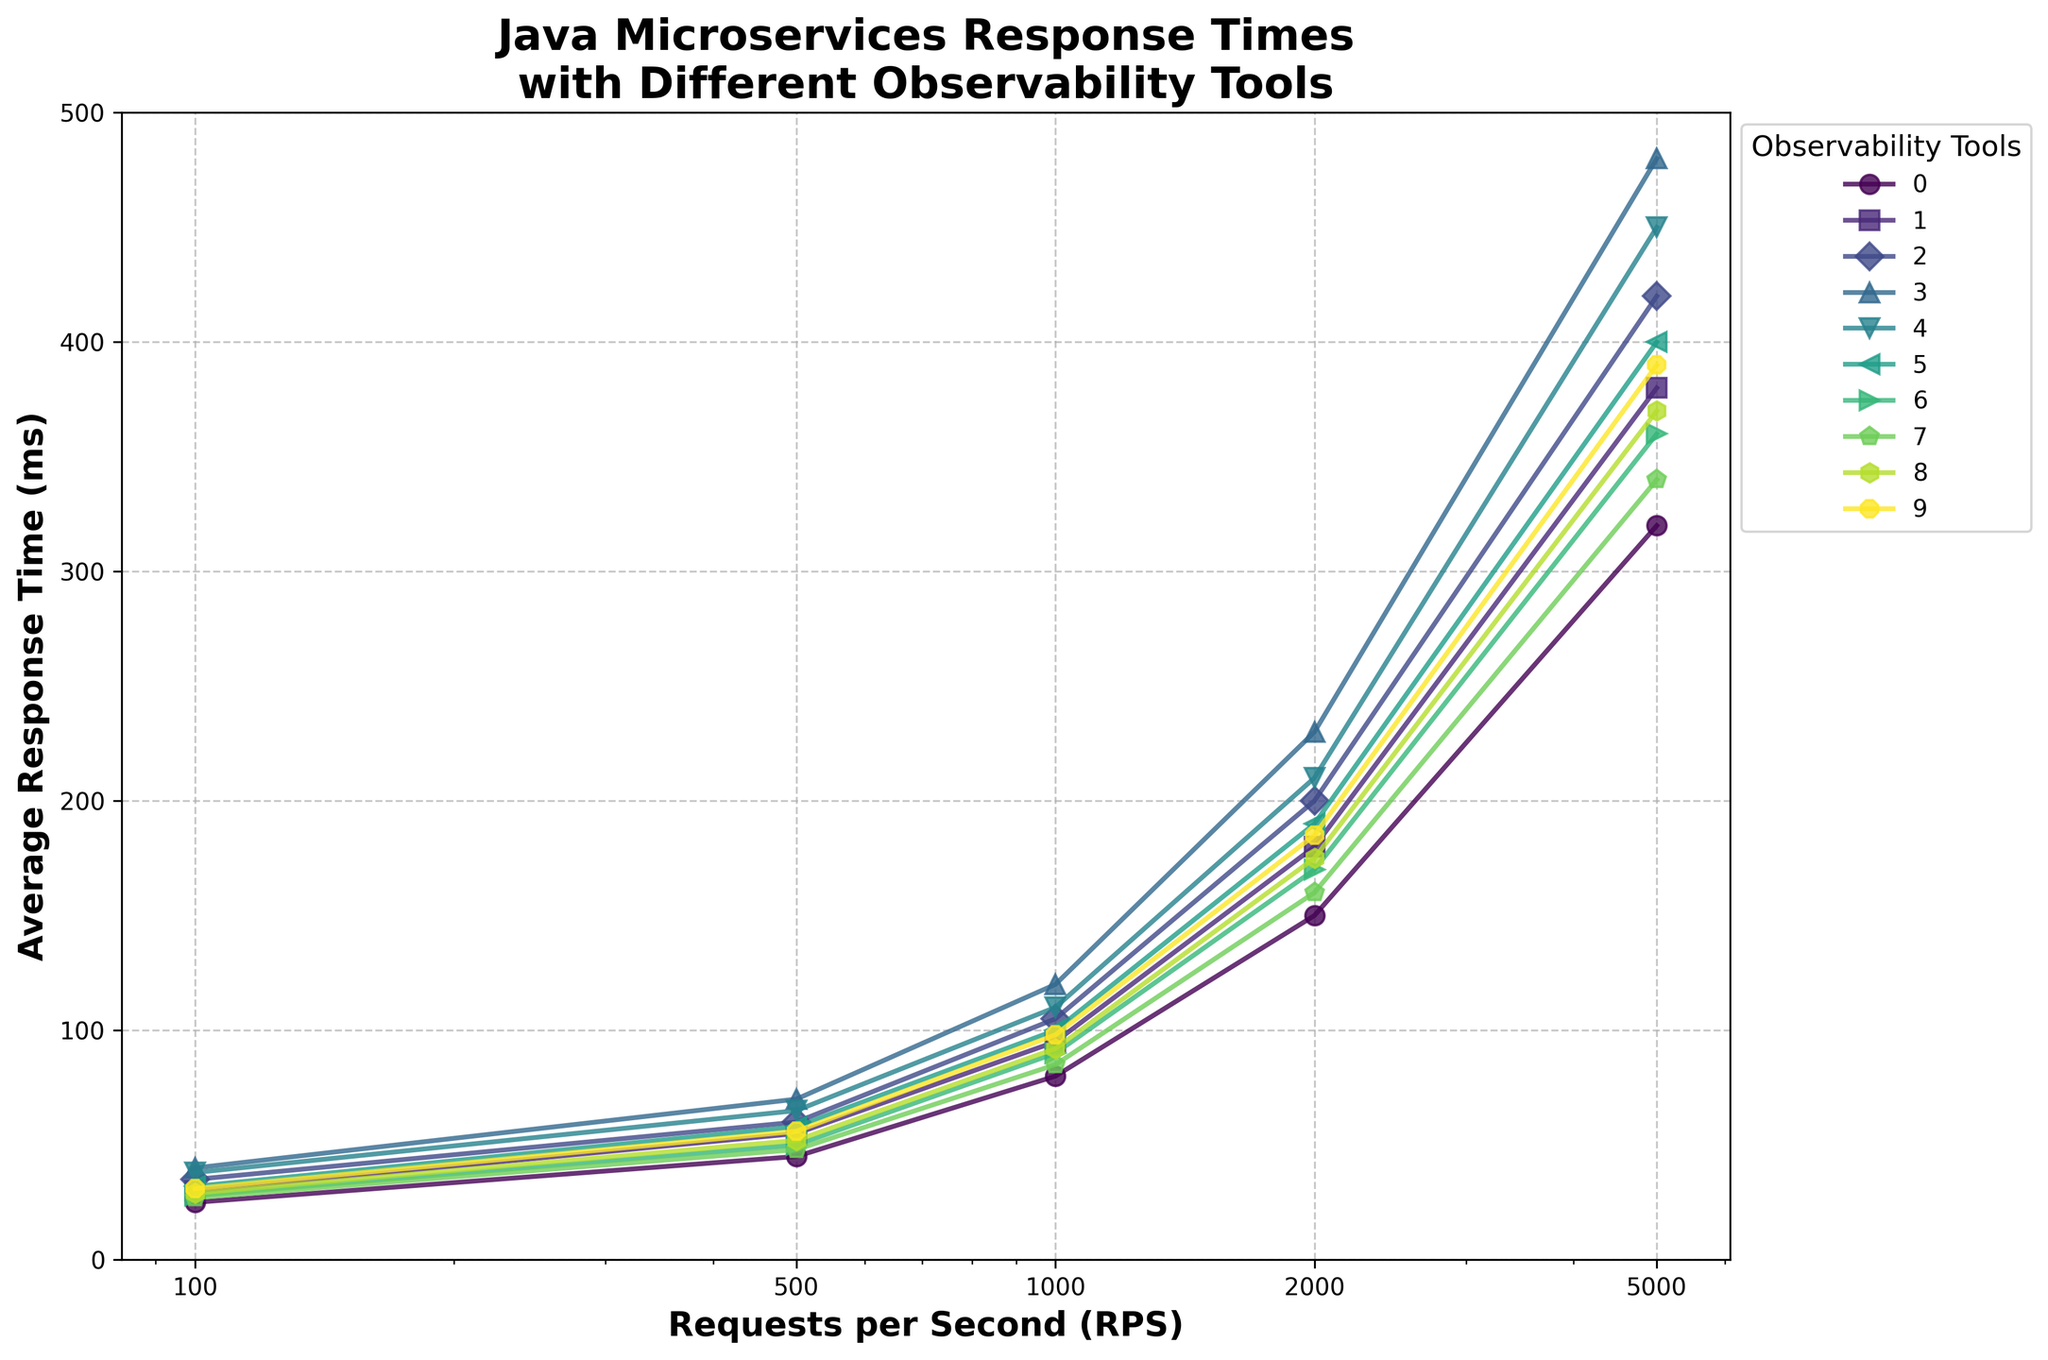What observability tool has the lowest average response time at 100 RPS? Look at the response times for all tools at 100 RPS in the figure. Compare the values and find the smallest one.
Answer: Spring Boot Actuator Which observability tool shows the fastest increase in average response time from 1000 RPS to 2000 RPS? Calculate the difference in response times between 1000 RPS and 2000 RPS for each tool. Identify the tool with the largest increase.
Answer: Jaeger Among the observability tools, which one has a higher average response time at 5000 RPS: OpenTelemetry or Zipkin? Compare the average response times of OpenTelemetry and Zipkin at 5000 RPS directly from the figure.
Answer: Zipkin What's the average response time for Datadog APM at 100 RPS and 5000 RPS? Add the response times of Datadog APM at 100 RPS and 5000 RPS, then divide by 2 to find the average.
Answer: 210.5 ms Which observability tool has a response time of around 170 ms at 2000 RPS? Refer to the response times at 2000 RPS for all tools in the figure and find the value that is nearest to 170 ms.
Answer: New Relic At 1000 RPS, is there any observability tool performing better than Dynatrace? Compare the average response time values of Dynatrace with all other tools at 1000 RPS. Determine if any tools have lower response times.
Answer: Yes, Spring Boot Actuator Which tool has the least variance in response times across all RPS levels? Calculate the variance of response times for each tool across all RPS levels and identify the tool with the smallest variance.
Answer: Spring Boot Actuator Between which requests per second (RPS) intervals does Elastic APM show the largest increase in response time? Calculate the difference in response times for Elastic APM between each consecutive RPS interval and find the largest increase.
Answer: 2000 to 5000 RPS Count the number of observability tools with an average response time of less than 50 ms at 500 RPS. Identify and count all tools with response times below 50 ms at 500 RPS from the figure.
Answer: Two tools Which observability tool has a distinct blue color and what is its response time at 2000 RPS? Identify the observability tool colored distinctly in blue in the figure, and check its response time value at 2000 RPS.
Answer: Micrometer + Prometheus, 180 ms 